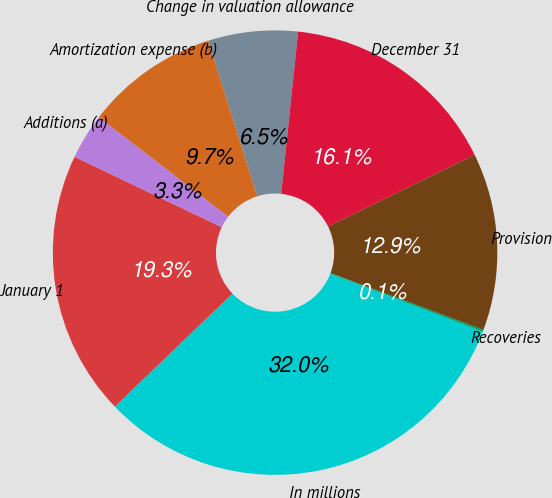<chart> <loc_0><loc_0><loc_500><loc_500><pie_chart><fcel>In millions<fcel>January 1<fcel>Additions (a)<fcel>Amortization expense (b)<fcel>Change in valuation allowance<fcel>December 31<fcel>Provision<fcel>Recoveries<nl><fcel>32.03%<fcel>19.28%<fcel>3.33%<fcel>9.71%<fcel>6.52%<fcel>16.09%<fcel>12.9%<fcel>0.14%<nl></chart> 